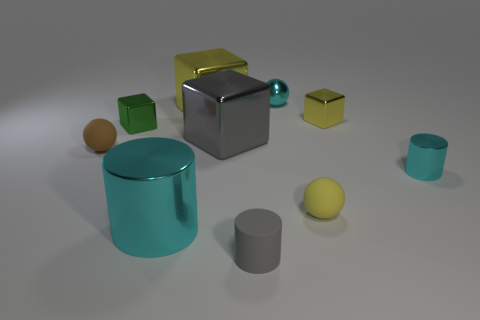What is the size of the gray cube that is the same material as the big cyan thing?
Your answer should be compact. Large. What is the size of the metal cylinder that is right of the large yellow thing behind the matte ball to the right of the small matte cylinder?
Provide a short and direct response. Small. There is a matte ball that is right of the brown thing; what is its color?
Your response must be concise. Yellow. Is the number of big cylinders that are in front of the matte cylinder greater than the number of large gray blocks?
Your response must be concise. No. There is a small metal object to the left of the gray rubber thing; does it have the same shape as the tiny yellow metal object?
Your response must be concise. Yes. What number of brown things are either big balls or cylinders?
Keep it short and to the point. 0. Is the number of big yellow metal objects greater than the number of small cyan things?
Your answer should be compact. No. There is a metallic cylinder that is the same size as the green metal thing; what color is it?
Your answer should be compact. Cyan. How many balls are tiny red metal things or yellow shiny objects?
Ensure brevity in your answer.  0. There is a large cyan object; is it the same shape as the tiny cyan shiny object in front of the big yellow cube?
Offer a terse response. Yes. 